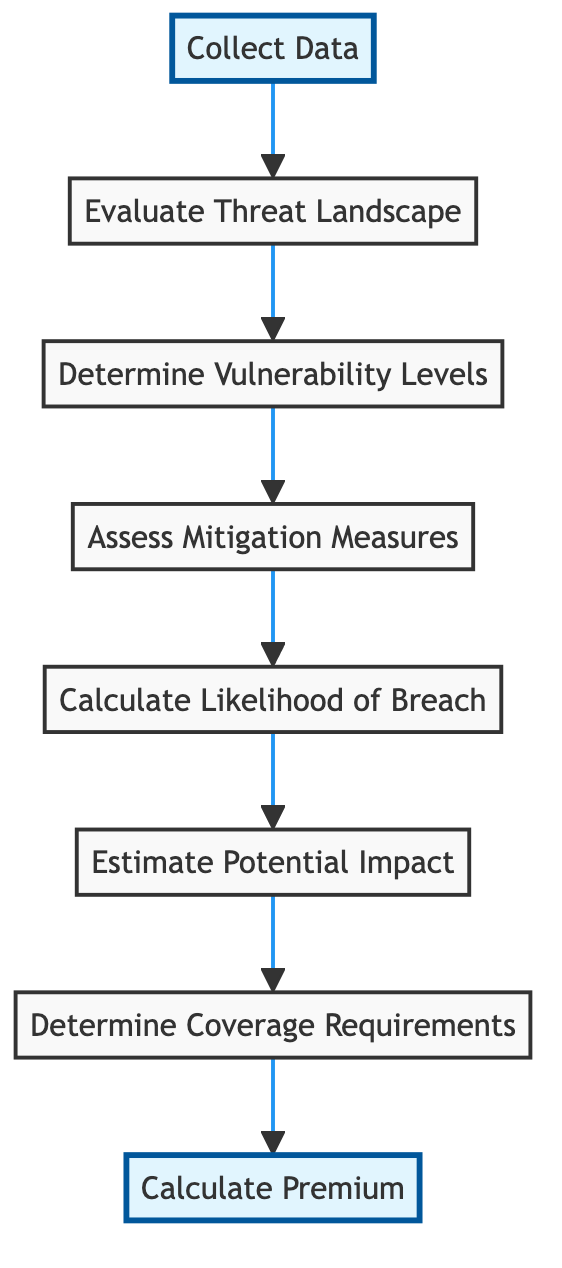What is the first step in the process? The first step, as indicated at the bottom of the diagram, is "Collect Data." This sets the initial action of gathering cybersecurity metrics and data from the client.
Answer: Collect Data How many nodes are there in the diagram? By counting all the individual steps listed in the diagram, there are a total of eight nodes representing distinct actions in the process of determining premiums based on cybersecurity metrics.
Answer: 8 What is the output of the "Assess Mitigation Measures"? The output from the "Assess Mitigation Measures" node is a "Mitigation effectiveness report." This indicates the effectiveness of the client's security controls after evaluation.
Answer: Mitigation effectiveness report Which node comes immediately after "Calculate Likelihood of Breach"? The node that follows "Calculate Likelihood of Breach" in the flow is "Estimate Potential Impact." This indicates the next step in the analysis process related to breach likelihood.
Answer: Estimate Potential Impact What inputs are required for the "Determine Coverage Requirements"? This step requires three inputs: "Breach likelihood score," "Impact assessment," and "client's coverage preferences," combining previous analyses to decide on coverage options.
Answer: Breach likelihood score, Impact assessment, client's coverage preferences What is the relationship between "Estimate Potential Impact" and "Calculate Premium"? "Estimate Potential Impact" provides necessary information that feeds into "Calculate Premium." Specifically, both the breach likelihood score and impact assessment from earlier steps are essential for determining the final insurance premium.
Answer: Input for Calculate Premium What action is taken prior to "Calculate Likelihood of Breach"? Before "Calculate Likelihood of Breach," the action "Assess Mitigation Measures" is taken. This step evaluates the effectiveness of security controls, influencing the likelihood of potential breaches.
Answer: Assess Mitigation Measures What does the "Collect Data" action produce? The action labeled "Collect Data" generates "Raw cybersecurity data," which serves as the fundamental input for all subsequent steps in the flow.
Answer: Raw cybersecurity data 